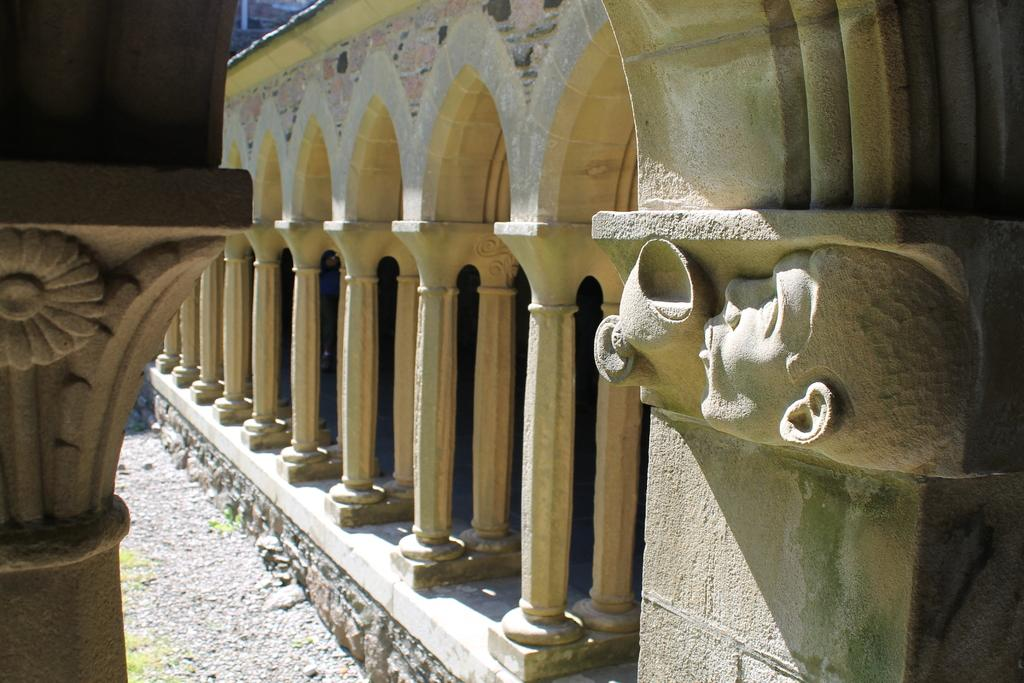What architectural features are present in the image? There are pillars with arches in the image. What decorative elements can be seen on the pillars? There are sculptures on the pillars. What type of rabbit can be seen interacting with the stranger in the image? There is no rabbit or stranger present in the image; it only features pillars with arches and sculptures on them. 